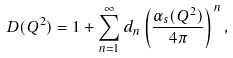<formula> <loc_0><loc_0><loc_500><loc_500>D ( Q ^ { 2 } ) = 1 + \sum _ { n = 1 } ^ { \infty } d _ { n } \left ( \frac { \alpha _ { s } ( Q ^ { 2 } ) } { 4 \pi } \right ) ^ { n } ,</formula> 